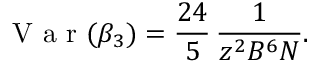Convert formula to latex. <formula><loc_0><loc_0><loc_500><loc_500>V a r ( \beta _ { 3 } ) = \frac { 2 4 } { 5 } \, \frac { 1 } { z ^ { 2 } B ^ { 6 } N } .</formula> 